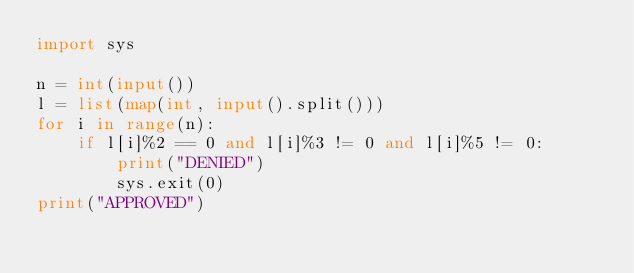<code> <loc_0><loc_0><loc_500><loc_500><_Python_>import sys

n = int(input())
l = list(map(int, input().split()))
for i in range(n):
    if l[i]%2 == 0 and l[i]%3 != 0 and l[i]%5 != 0:
        print("DENIED")
        sys.exit(0)
print("APPROVED")</code> 